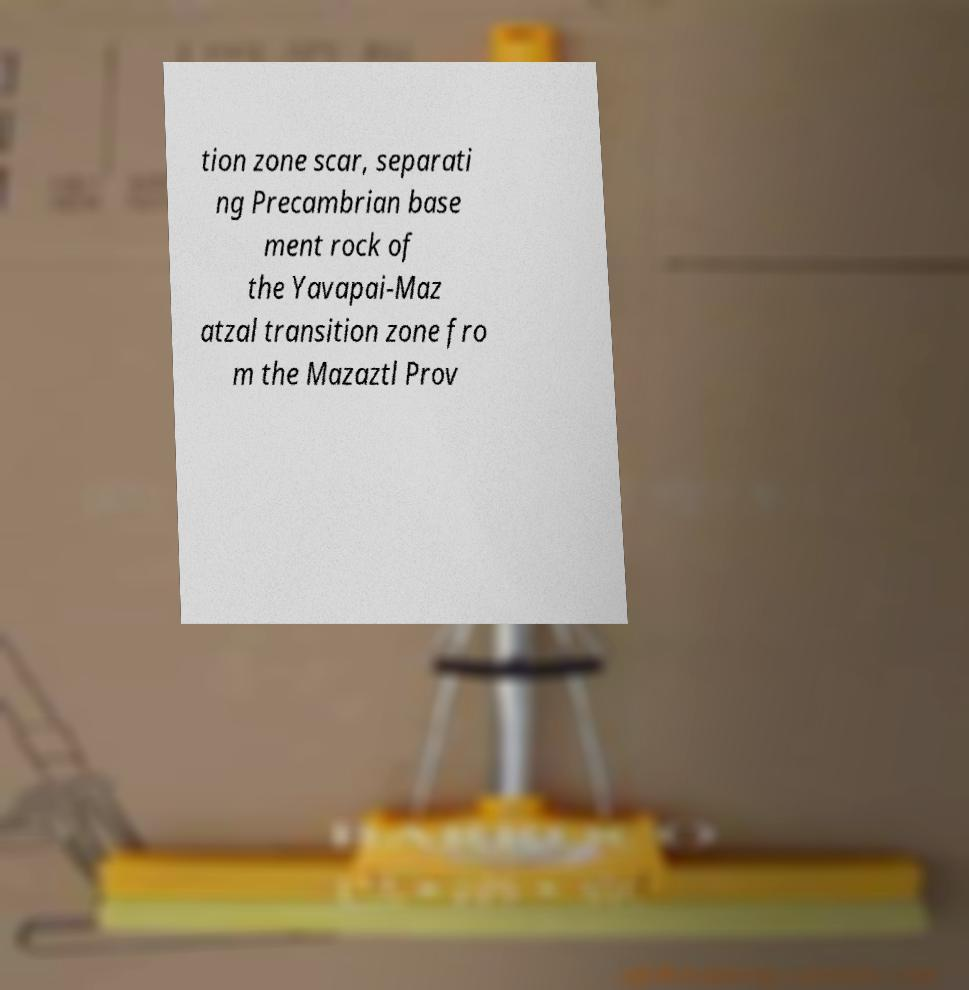Can you read and provide the text displayed in the image?This photo seems to have some interesting text. Can you extract and type it out for me? tion zone scar, separati ng Precambrian base ment rock of the Yavapai-Maz atzal transition zone fro m the Mazaztl Prov 